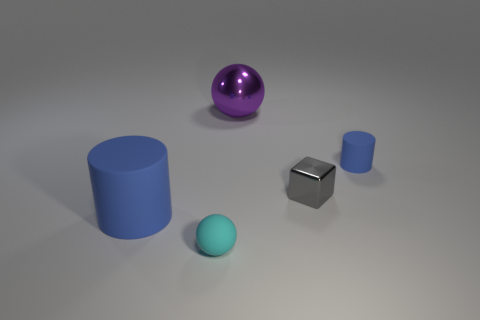What can you infer about the setting or context where these objects are placed? The objects are arranged on what appears to be a flat surface with a neutral grey color, likely inside a room with artificial lighting that casts soft shadows. The simplicity of the scene suggests it might be rendered for a graphical exercise, demonstrating different geometrical shapes and materials under controlled lighting. 